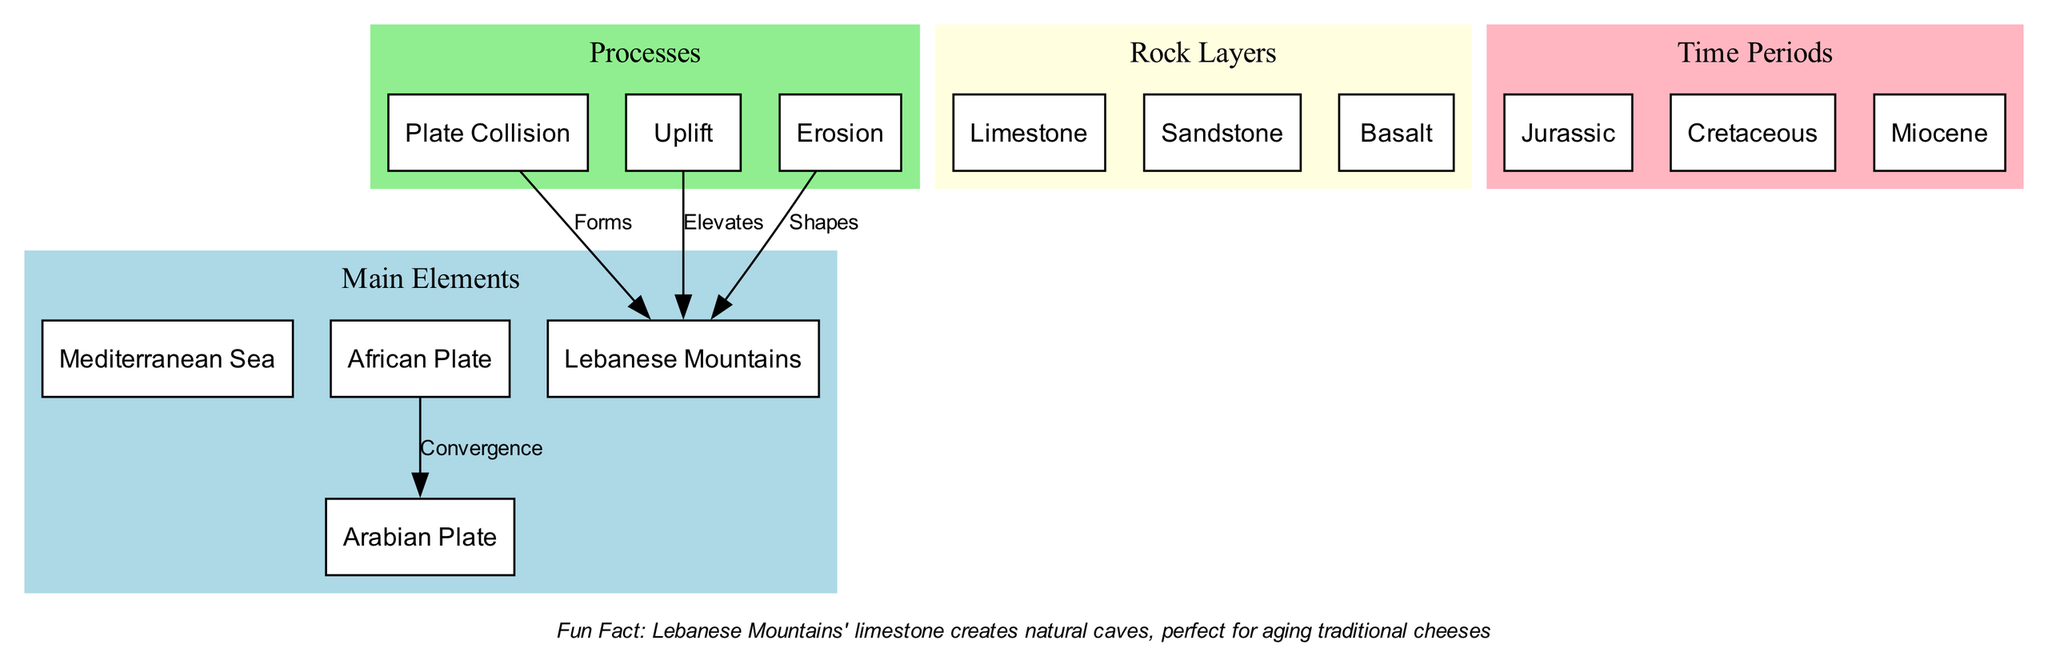What are the main elements depicted in the diagram? The diagram lists four main elements: the Mediterranean Sea, African Plate, Arabian Plate, and Lebanese Mountains. Each is indicated in the 'Main Elements' section, clearly labeled as individual entities within the subgraph.
Answer: Mediterranean Sea, African Plate, Arabian Plate, Lebanese Mountains How many rock layers are represented in the diagram? There are three distinct rock layers shown in the 'Rock Layers' section, which includes limestone, sandstone, and basalt. The total can be counted by observing the nodes in that specific cluster.
Answer: 3 What process is labeled as forming the Lebanese Mountains? The process of "Plate Collision" is explicitly labeled with the edge connecting it to "Lebanese Mountains," indicating that this event is a key contributing factor in their formation.
Answer: Forms Which plate is identified as converging with the African Plate? The diagram indicates that the Arabian Plate is converging with the African Plate. This relationship is shown through a clearly labeled connection pointing from the African Plate to the Arabian Plate.
Answer: Arabian Plate What is the role of erosion in relation to the Lebanese Mountains? Erosion is indicated in the diagram as the process that 'Shapes' the Lebanese Mountains. This connection highlights its significance in modifying the landscape over time.
Answer: Shapes During which time period does the uplift process occur? The uplift process is linked with multiple geological time periods, but it specifically relates to the Miocene period, indicated as associated with the overall elevation of the mountains.
Answer: Miocene What rock layer is primarily associated with the Lebanese Mountains? Limestone is the rock layer most closely associated with the Lebanese Mountains, as it is the primary rock type listed in the 'Rock Layers' section of the diagram.
Answer: Limestone How does the diagram illustrate the relationship between uplift and the Lebanese Mountains? The diagram connects the process of Uplift directly to the Lebanese Mountains with a labeled edge indicating that uplift 'Elevates' these mountains, highlighting the direct impact of this geological activity.
Answer: Elevates What fun fact is noted about the Lebanese Mountains? The fun fact mentioned in the diagram states that the limestone in the Lebanese Mountains creates natural caves, which are ideal for aging traditional cheeses. This fact is presented separately at the bottom of the diagram.
Answer: Lebanese Mountains' limestone creates natural caves, perfect for aging traditional cheeses 